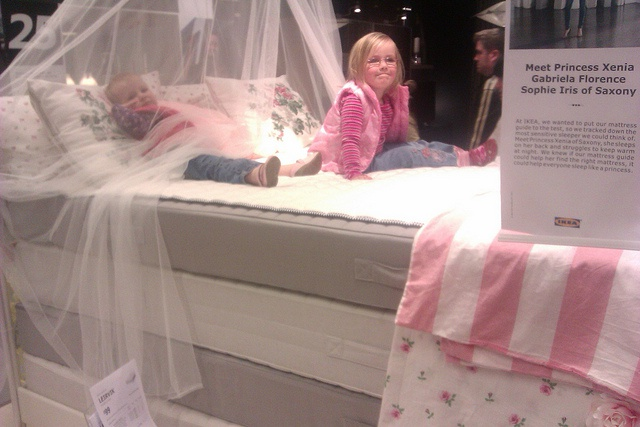Describe the objects in this image and their specific colors. I can see bed in black, darkgray, gray, and white tones, people in black, lightpink, gray, and darkgray tones, people in black, brown, lightpink, salmon, and gray tones, and people in black, maroon, and brown tones in this image. 